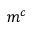<formula> <loc_0><loc_0><loc_500><loc_500>m ^ { c }</formula> 